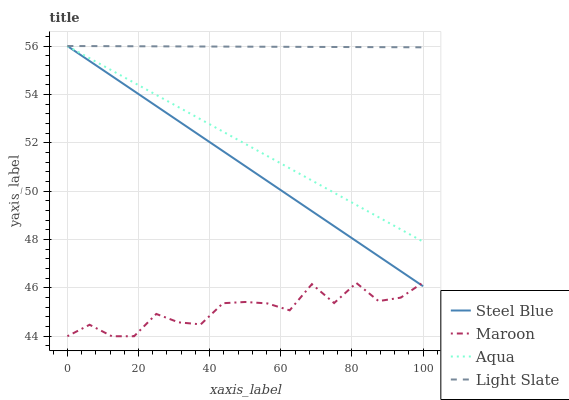Does Maroon have the minimum area under the curve?
Answer yes or no. Yes. Does Light Slate have the maximum area under the curve?
Answer yes or no. Yes. Does Aqua have the minimum area under the curve?
Answer yes or no. No. Does Aqua have the maximum area under the curve?
Answer yes or no. No. Is Aqua the smoothest?
Answer yes or no. Yes. Is Maroon the roughest?
Answer yes or no. Yes. Is Steel Blue the smoothest?
Answer yes or no. No. Is Steel Blue the roughest?
Answer yes or no. No. Does Maroon have the lowest value?
Answer yes or no. Yes. Does Aqua have the lowest value?
Answer yes or no. No. Does Steel Blue have the highest value?
Answer yes or no. Yes. Does Maroon have the highest value?
Answer yes or no. No. Is Maroon less than Aqua?
Answer yes or no. Yes. Is Light Slate greater than Maroon?
Answer yes or no. Yes. Does Steel Blue intersect Maroon?
Answer yes or no. Yes. Is Steel Blue less than Maroon?
Answer yes or no. No. Is Steel Blue greater than Maroon?
Answer yes or no. No. Does Maroon intersect Aqua?
Answer yes or no. No. 